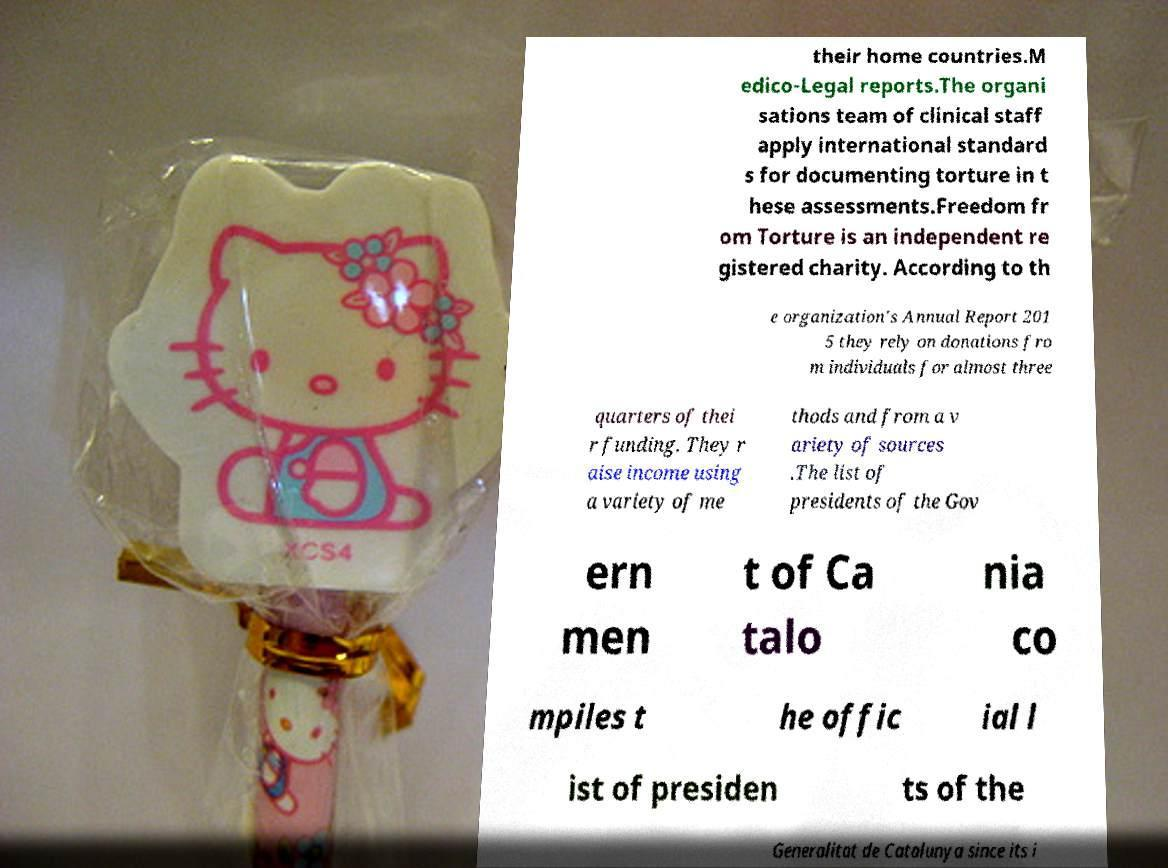There's text embedded in this image that I need extracted. Can you transcribe it verbatim? their home countries.M edico-Legal reports.The organi sations team of clinical staff apply international standard s for documenting torture in t hese assessments.Freedom fr om Torture is an independent re gistered charity. According to th e organization's Annual Report 201 5 they rely on donations fro m individuals for almost three quarters of thei r funding. They r aise income using a variety of me thods and from a v ariety of sources .The list of presidents of the Gov ern men t of Ca talo nia co mpiles t he offic ial l ist of presiden ts of the Generalitat de Catalunya since its i 